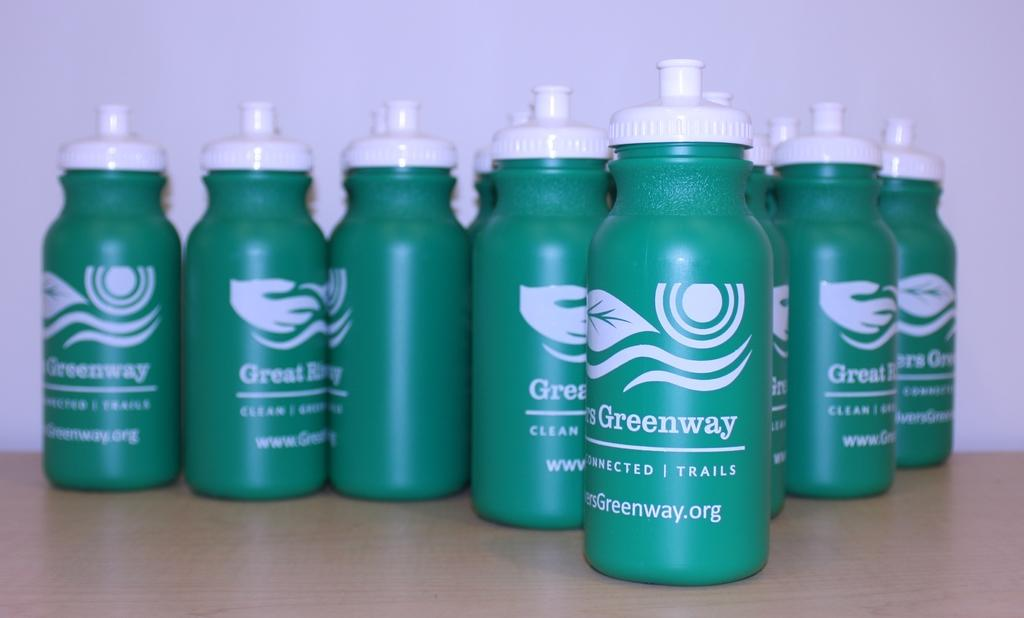What color are the bottles in the image? The bottles in the image are green. Where are the green bottles located? The green bottles are on a table. What type of copper tank can be seen in the image? There is no copper tank present in the image; it only features green bottles on a table. What is the head doing in the image? There is no head present in the image. 